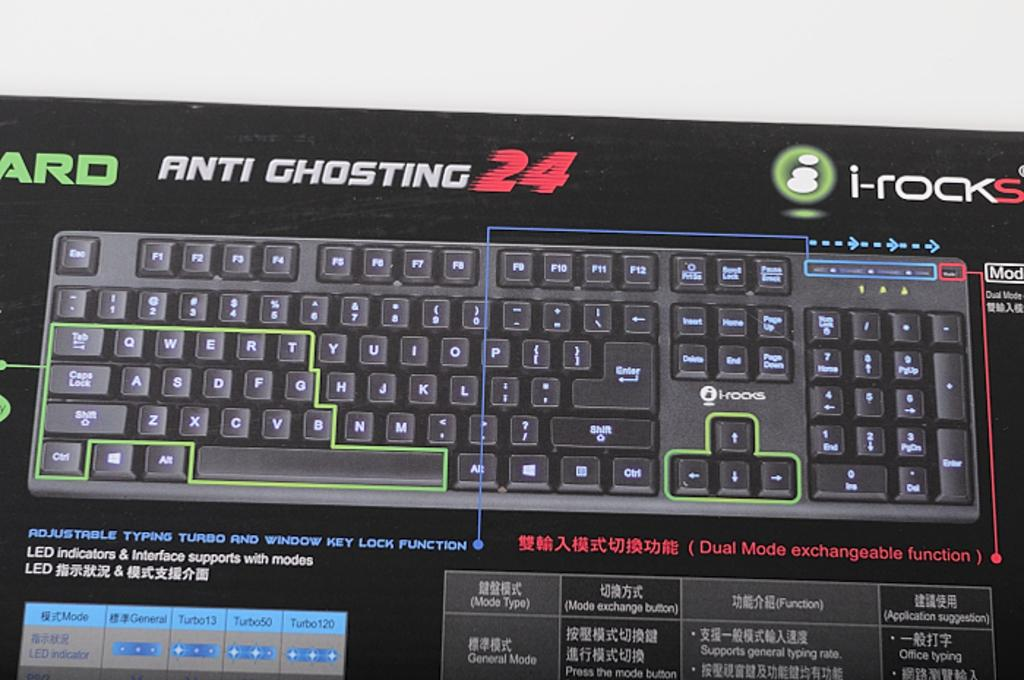<image>
Summarize the visual content of the image. An advanced keyboard proudly declares its anti ghosting capability on its box. 